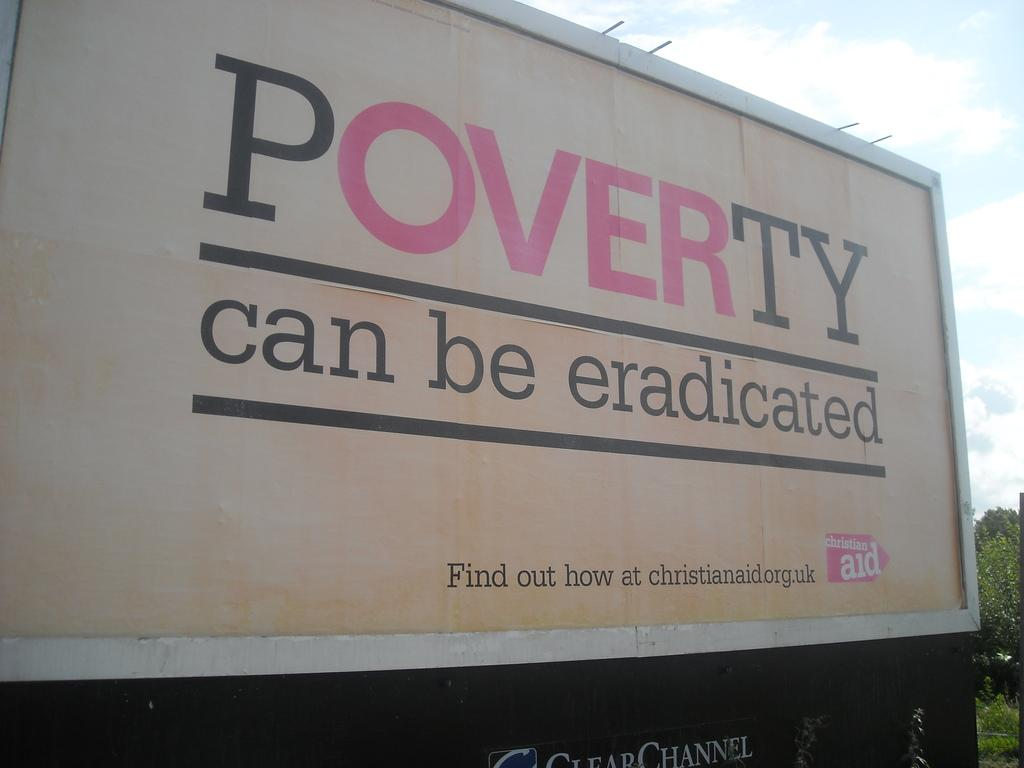<image>
Offer a succinct explanation of the picture presented. a billboard on a road reads Poverty can be eradicated 